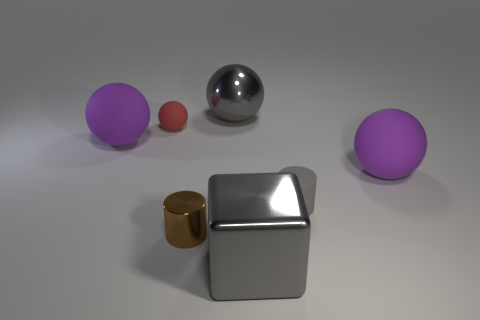Subtract all big gray metallic spheres. How many spheres are left? 3 Subtract all gray balls. How many balls are left? 3 Add 2 yellow balls. How many objects exist? 9 Subtract all gray cubes. How many purple spheres are left? 2 Subtract all cylinders. How many objects are left? 5 Subtract all yellow cylinders. Subtract all yellow blocks. How many cylinders are left? 2 Subtract all balls. Subtract all large matte balls. How many objects are left? 1 Add 1 rubber things. How many rubber things are left? 5 Add 5 large metallic objects. How many large metallic objects exist? 7 Subtract 0 blue cylinders. How many objects are left? 7 